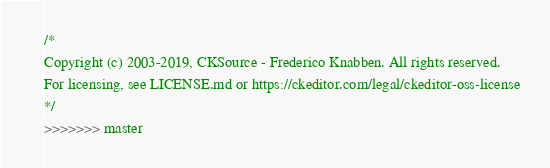<code> <loc_0><loc_0><loc_500><loc_500><_CSS_>/*
Copyright (c) 2003-2019, CKSource - Frederico Knabben. All rights reserved.
For licensing, see LICENSE.md or https://ckeditor.com/legal/ckeditor-oss-license
*/
>>>>>>> master</code> 